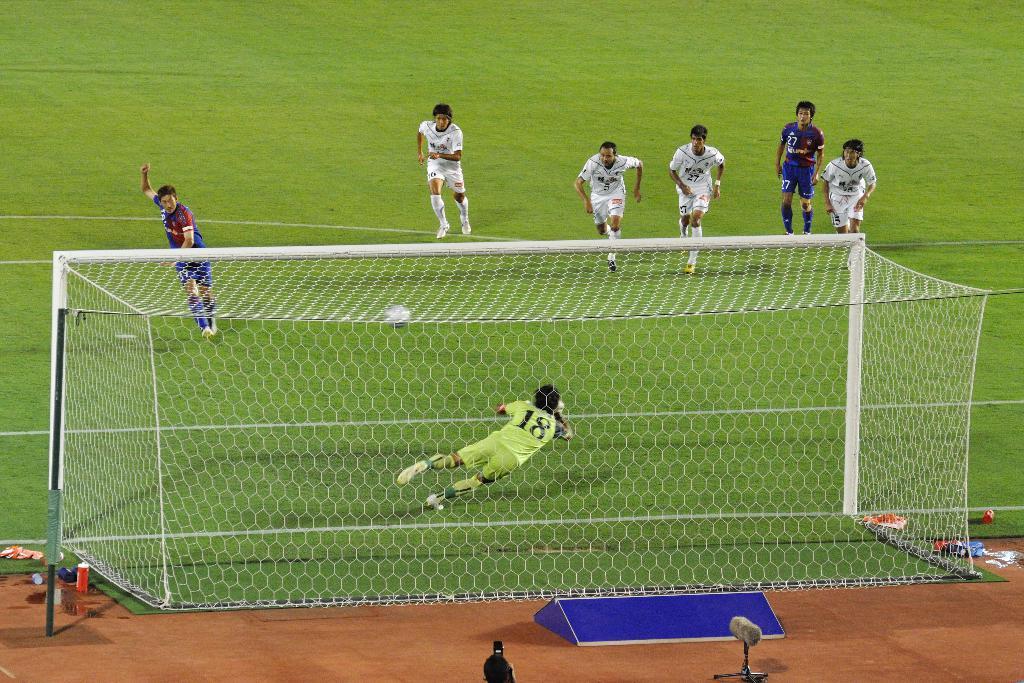What is the goalie's number?
Your answer should be compact. 18. What number is the top right, dark shirt player?
Ensure brevity in your answer.  27. 